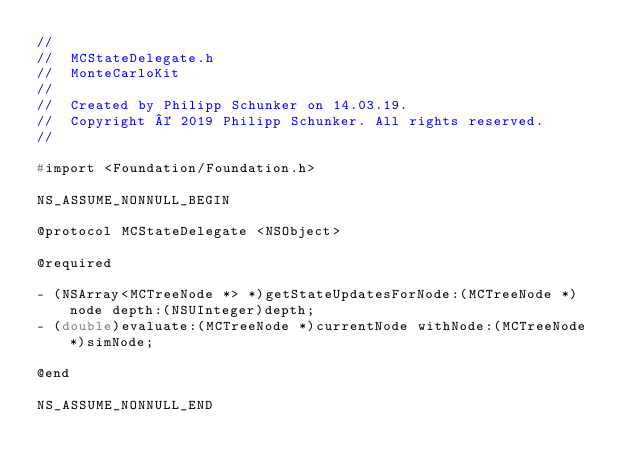Convert code to text. <code><loc_0><loc_0><loc_500><loc_500><_C_>//
//  MCStateDelegate.h
//  MonteCarloKit
//
//  Created by Philipp Schunker on 14.03.19.
//  Copyright © 2019 Philipp Schunker. All rights reserved.
//

#import <Foundation/Foundation.h>

NS_ASSUME_NONNULL_BEGIN

@protocol MCStateDelegate <NSObject>

@required

- (NSArray<MCTreeNode *> *)getStateUpdatesForNode:(MCTreeNode *)node depth:(NSUInteger)depth;
- (double)evaluate:(MCTreeNode *)currentNode withNode:(MCTreeNode *)simNode;

@end

NS_ASSUME_NONNULL_END
</code> 